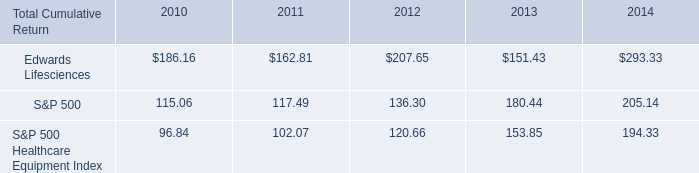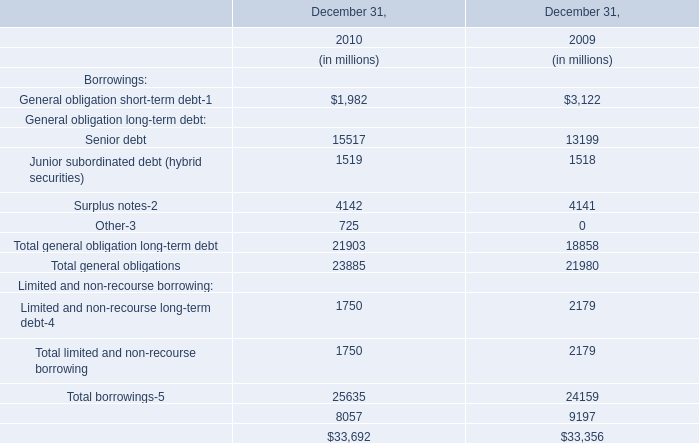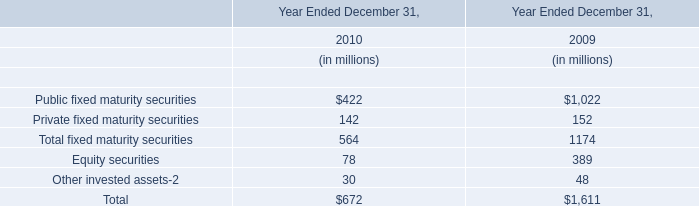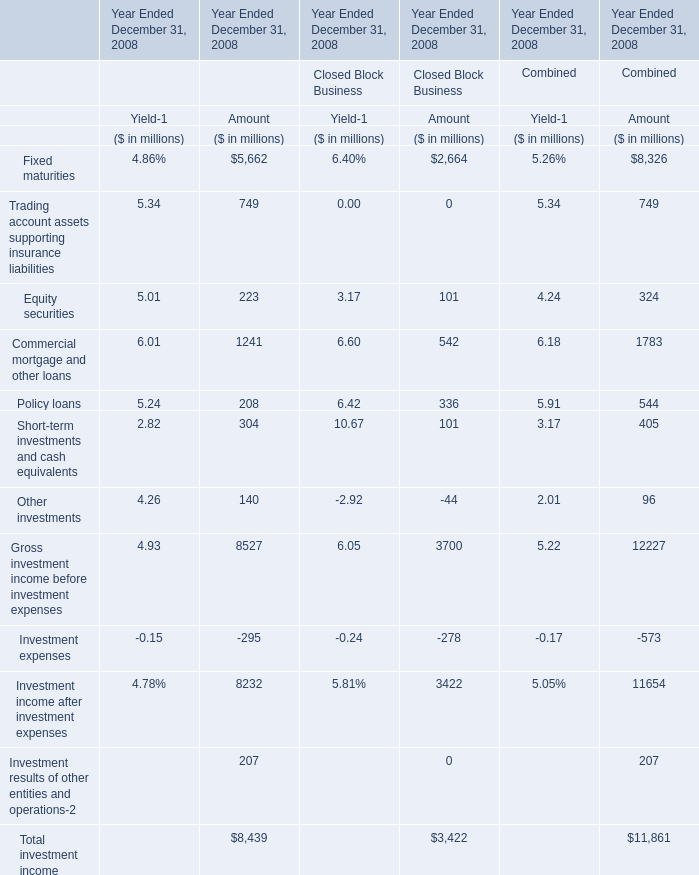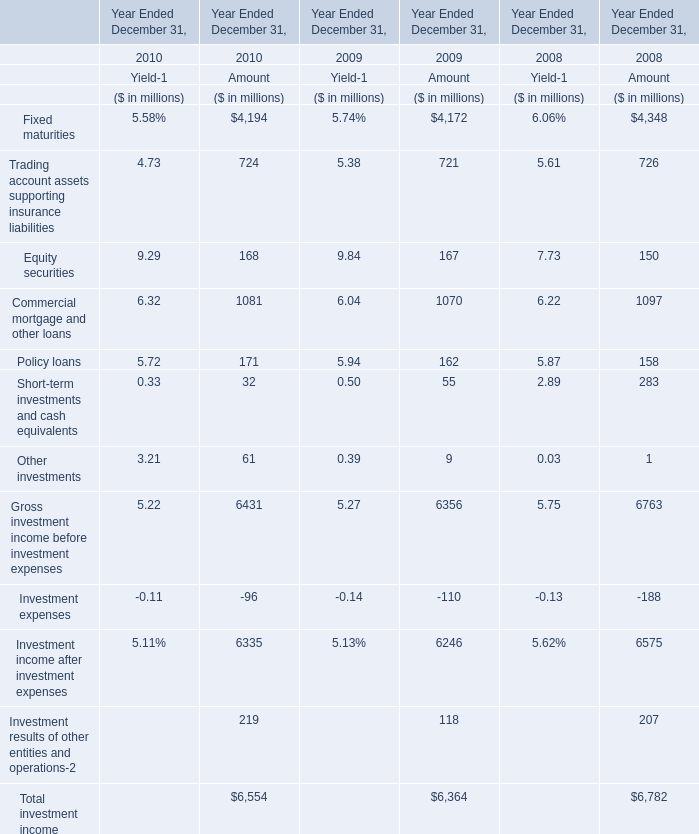what was the 5 year cumulative total return for the period ending 2014 for edwards lifesciences corporation? 
Computations: ((293.33 - 100) / 100)
Answer: 1.9333. 